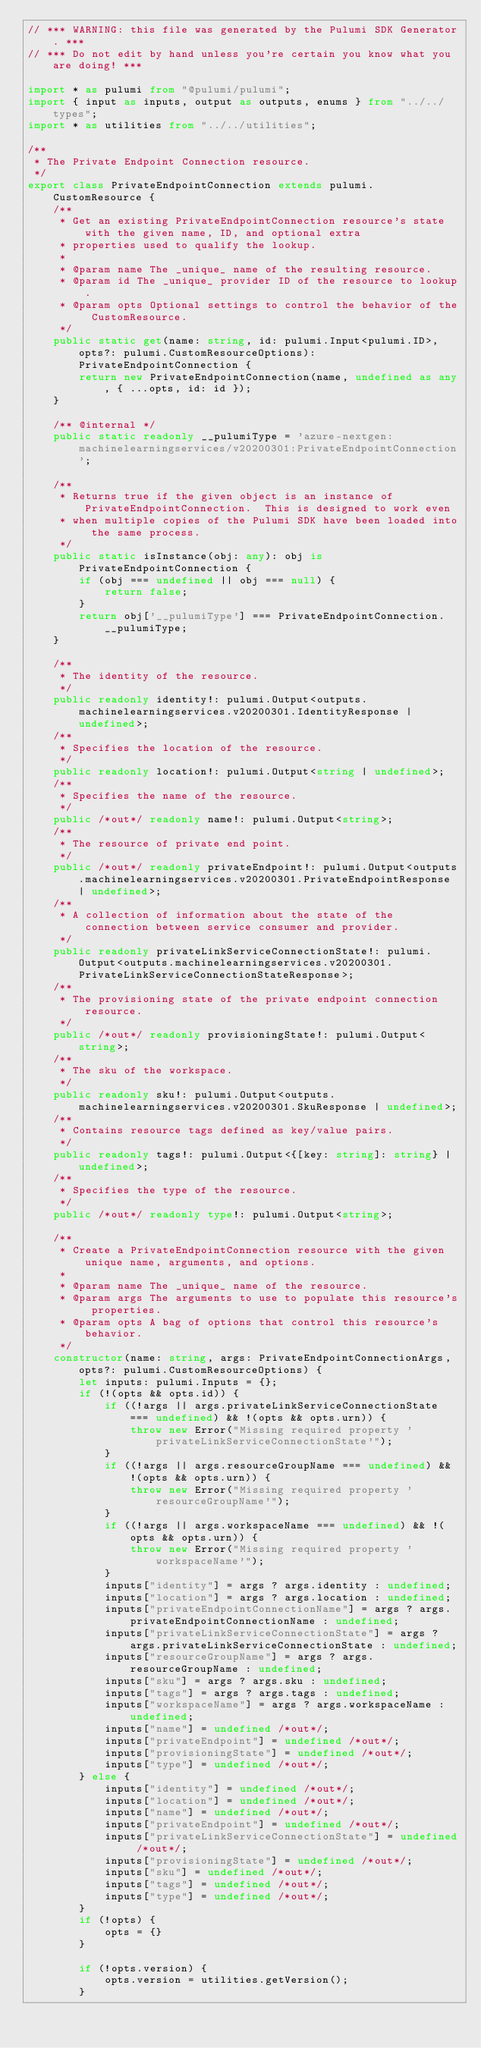Convert code to text. <code><loc_0><loc_0><loc_500><loc_500><_TypeScript_>// *** WARNING: this file was generated by the Pulumi SDK Generator. ***
// *** Do not edit by hand unless you're certain you know what you are doing! ***

import * as pulumi from "@pulumi/pulumi";
import { input as inputs, output as outputs, enums } from "../../types";
import * as utilities from "../../utilities";

/**
 * The Private Endpoint Connection resource.
 */
export class PrivateEndpointConnection extends pulumi.CustomResource {
    /**
     * Get an existing PrivateEndpointConnection resource's state with the given name, ID, and optional extra
     * properties used to qualify the lookup.
     *
     * @param name The _unique_ name of the resulting resource.
     * @param id The _unique_ provider ID of the resource to lookup.
     * @param opts Optional settings to control the behavior of the CustomResource.
     */
    public static get(name: string, id: pulumi.Input<pulumi.ID>, opts?: pulumi.CustomResourceOptions): PrivateEndpointConnection {
        return new PrivateEndpointConnection(name, undefined as any, { ...opts, id: id });
    }

    /** @internal */
    public static readonly __pulumiType = 'azure-nextgen:machinelearningservices/v20200301:PrivateEndpointConnection';

    /**
     * Returns true if the given object is an instance of PrivateEndpointConnection.  This is designed to work even
     * when multiple copies of the Pulumi SDK have been loaded into the same process.
     */
    public static isInstance(obj: any): obj is PrivateEndpointConnection {
        if (obj === undefined || obj === null) {
            return false;
        }
        return obj['__pulumiType'] === PrivateEndpointConnection.__pulumiType;
    }

    /**
     * The identity of the resource.
     */
    public readonly identity!: pulumi.Output<outputs.machinelearningservices.v20200301.IdentityResponse | undefined>;
    /**
     * Specifies the location of the resource.
     */
    public readonly location!: pulumi.Output<string | undefined>;
    /**
     * Specifies the name of the resource.
     */
    public /*out*/ readonly name!: pulumi.Output<string>;
    /**
     * The resource of private end point.
     */
    public /*out*/ readonly privateEndpoint!: pulumi.Output<outputs.machinelearningservices.v20200301.PrivateEndpointResponse | undefined>;
    /**
     * A collection of information about the state of the connection between service consumer and provider.
     */
    public readonly privateLinkServiceConnectionState!: pulumi.Output<outputs.machinelearningservices.v20200301.PrivateLinkServiceConnectionStateResponse>;
    /**
     * The provisioning state of the private endpoint connection resource.
     */
    public /*out*/ readonly provisioningState!: pulumi.Output<string>;
    /**
     * The sku of the workspace.
     */
    public readonly sku!: pulumi.Output<outputs.machinelearningservices.v20200301.SkuResponse | undefined>;
    /**
     * Contains resource tags defined as key/value pairs.
     */
    public readonly tags!: pulumi.Output<{[key: string]: string} | undefined>;
    /**
     * Specifies the type of the resource.
     */
    public /*out*/ readonly type!: pulumi.Output<string>;

    /**
     * Create a PrivateEndpointConnection resource with the given unique name, arguments, and options.
     *
     * @param name The _unique_ name of the resource.
     * @param args The arguments to use to populate this resource's properties.
     * @param opts A bag of options that control this resource's behavior.
     */
    constructor(name: string, args: PrivateEndpointConnectionArgs, opts?: pulumi.CustomResourceOptions) {
        let inputs: pulumi.Inputs = {};
        if (!(opts && opts.id)) {
            if ((!args || args.privateLinkServiceConnectionState === undefined) && !(opts && opts.urn)) {
                throw new Error("Missing required property 'privateLinkServiceConnectionState'");
            }
            if ((!args || args.resourceGroupName === undefined) && !(opts && opts.urn)) {
                throw new Error("Missing required property 'resourceGroupName'");
            }
            if ((!args || args.workspaceName === undefined) && !(opts && opts.urn)) {
                throw new Error("Missing required property 'workspaceName'");
            }
            inputs["identity"] = args ? args.identity : undefined;
            inputs["location"] = args ? args.location : undefined;
            inputs["privateEndpointConnectionName"] = args ? args.privateEndpointConnectionName : undefined;
            inputs["privateLinkServiceConnectionState"] = args ? args.privateLinkServiceConnectionState : undefined;
            inputs["resourceGroupName"] = args ? args.resourceGroupName : undefined;
            inputs["sku"] = args ? args.sku : undefined;
            inputs["tags"] = args ? args.tags : undefined;
            inputs["workspaceName"] = args ? args.workspaceName : undefined;
            inputs["name"] = undefined /*out*/;
            inputs["privateEndpoint"] = undefined /*out*/;
            inputs["provisioningState"] = undefined /*out*/;
            inputs["type"] = undefined /*out*/;
        } else {
            inputs["identity"] = undefined /*out*/;
            inputs["location"] = undefined /*out*/;
            inputs["name"] = undefined /*out*/;
            inputs["privateEndpoint"] = undefined /*out*/;
            inputs["privateLinkServiceConnectionState"] = undefined /*out*/;
            inputs["provisioningState"] = undefined /*out*/;
            inputs["sku"] = undefined /*out*/;
            inputs["tags"] = undefined /*out*/;
            inputs["type"] = undefined /*out*/;
        }
        if (!opts) {
            opts = {}
        }

        if (!opts.version) {
            opts.version = utilities.getVersion();
        }</code> 